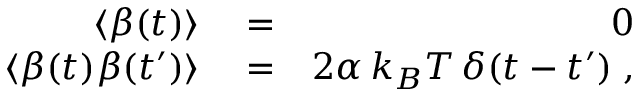Convert formula to latex. <formula><loc_0><loc_0><loc_500><loc_500>\begin{array} { r l r } { \langle \beta ( t ) \rangle } & = } & { 0 } \\ { \langle \beta ( t ) \beta ( t ^ { \prime } ) \rangle } & = } & { 2 \alpha \, k _ { B } T \, \delta ( t - t ^ { \prime } ) \, , } \end{array}</formula> 